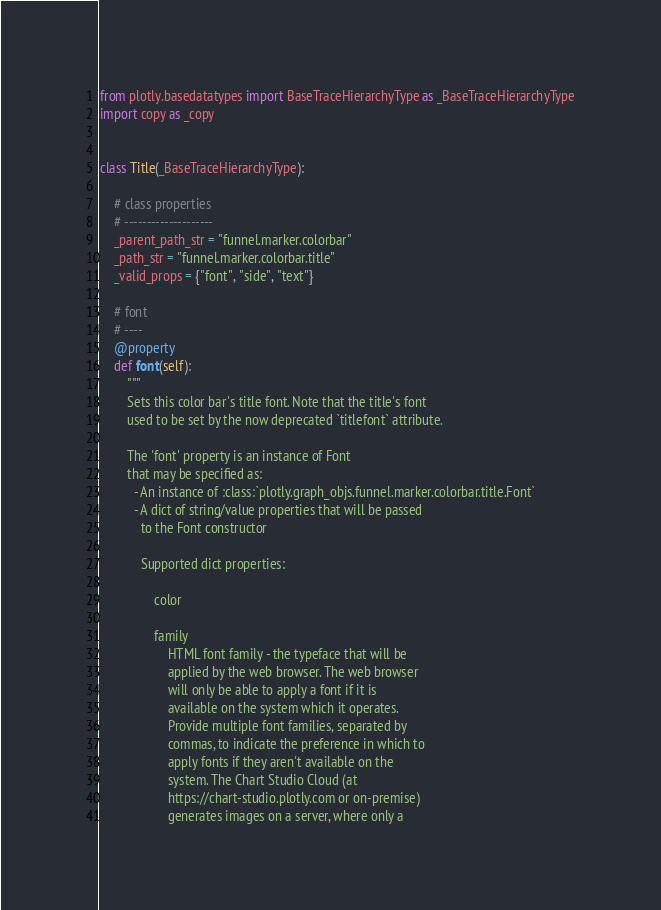Convert code to text. <code><loc_0><loc_0><loc_500><loc_500><_Python_>from plotly.basedatatypes import BaseTraceHierarchyType as _BaseTraceHierarchyType
import copy as _copy


class Title(_BaseTraceHierarchyType):

    # class properties
    # --------------------
    _parent_path_str = "funnel.marker.colorbar"
    _path_str = "funnel.marker.colorbar.title"
    _valid_props = {"font", "side", "text"}

    # font
    # ----
    @property
    def font(self):
        """
        Sets this color bar's title font. Note that the title's font
        used to be set by the now deprecated `titlefont` attribute.

        The 'font' property is an instance of Font
        that may be specified as:
          - An instance of :class:`plotly.graph_objs.funnel.marker.colorbar.title.Font`
          - A dict of string/value properties that will be passed
            to the Font constructor

            Supported dict properties:

                color

                family
                    HTML font family - the typeface that will be
                    applied by the web browser. The web browser
                    will only be able to apply a font if it is
                    available on the system which it operates.
                    Provide multiple font families, separated by
                    commas, to indicate the preference in which to
                    apply fonts if they aren't available on the
                    system. The Chart Studio Cloud (at
                    https://chart-studio.plotly.com or on-premise)
                    generates images on a server, where only a</code> 